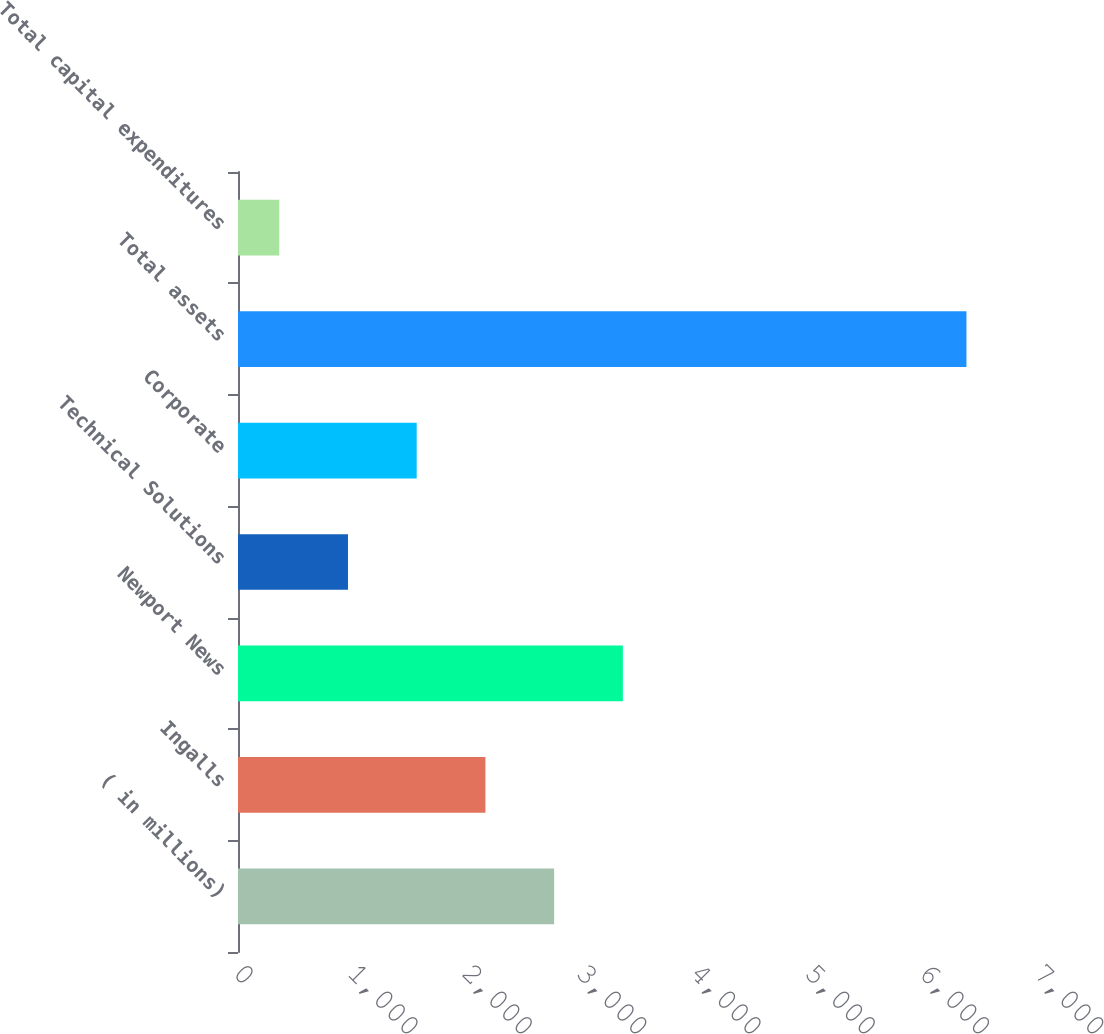Convert chart. <chart><loc_0><loc_0><loc_500><loc_500><bar_chart><fcel>( in millions)<fcel>Ingalls<fcel>Newport News<fcel>Technical Solutions<fcel>Corporate<fcel>Total assets<fcel>Total capital expenditures<nl><fcel>2766.2<fcel>2164.9<fcel>3367.5<fcel>962.3<fcel>1563.6<fcel>6374<fcel>361<nl></chart> 